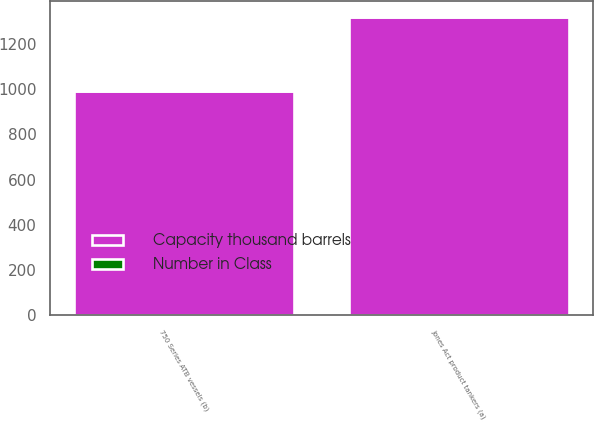<chart> <loc_0><loc_0><loc_500><loc_500><stacked_bar_chart><ecel><fcel>Jones Act product tankers (a)<fcel>750 Series ATB vessels (b)<nl><fcel>Number in Class<fcel>4<fcel>3<nl><fcel>Capacity thousand barrels<fcel>1320<fcel>990<nl></chart> 